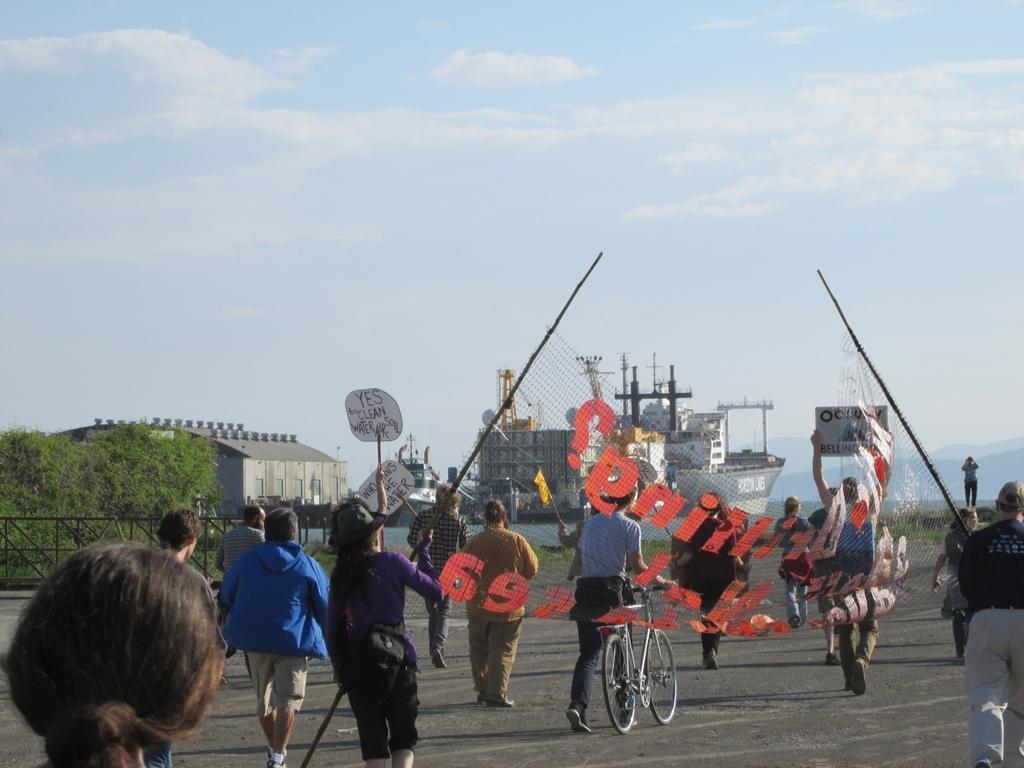Can you describe this image briefly? In this image I can see the ground, few persons standing, some of them are holding the net, some of them are holding boards, a person is holding a bicycle. In the background I can see few trees, the fencing, a ship , few mountains and the sky. 